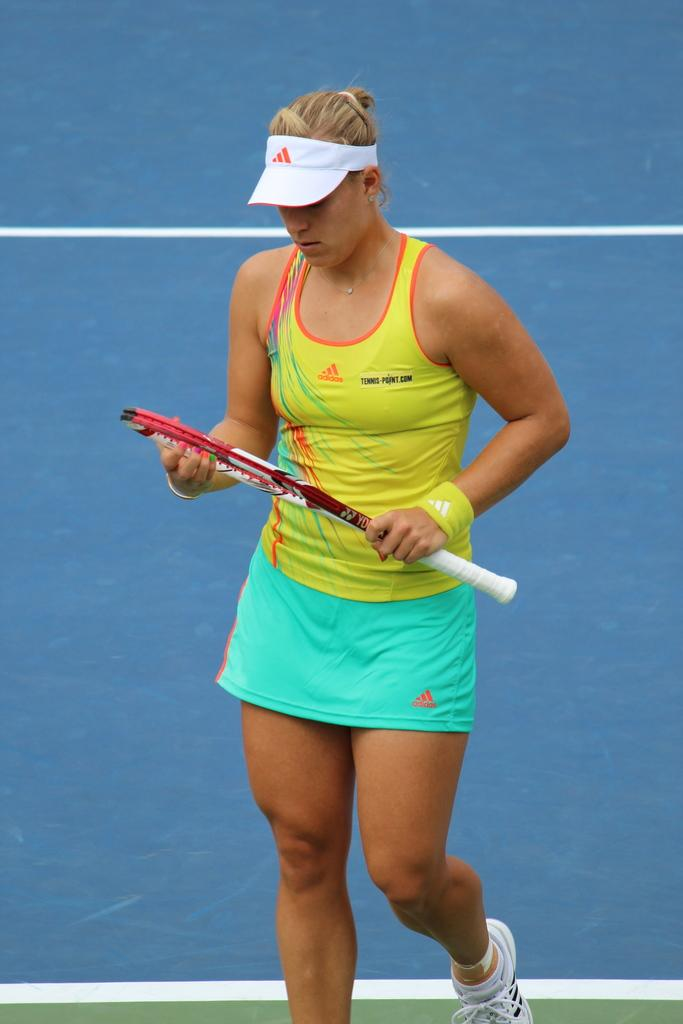Who is present in the image? There is a woman in the image. How many feet are visible in the woman's pocket in the image? There are no feet visible in the woman's pocket in the image, as pockets are not large enough to hold feet. 